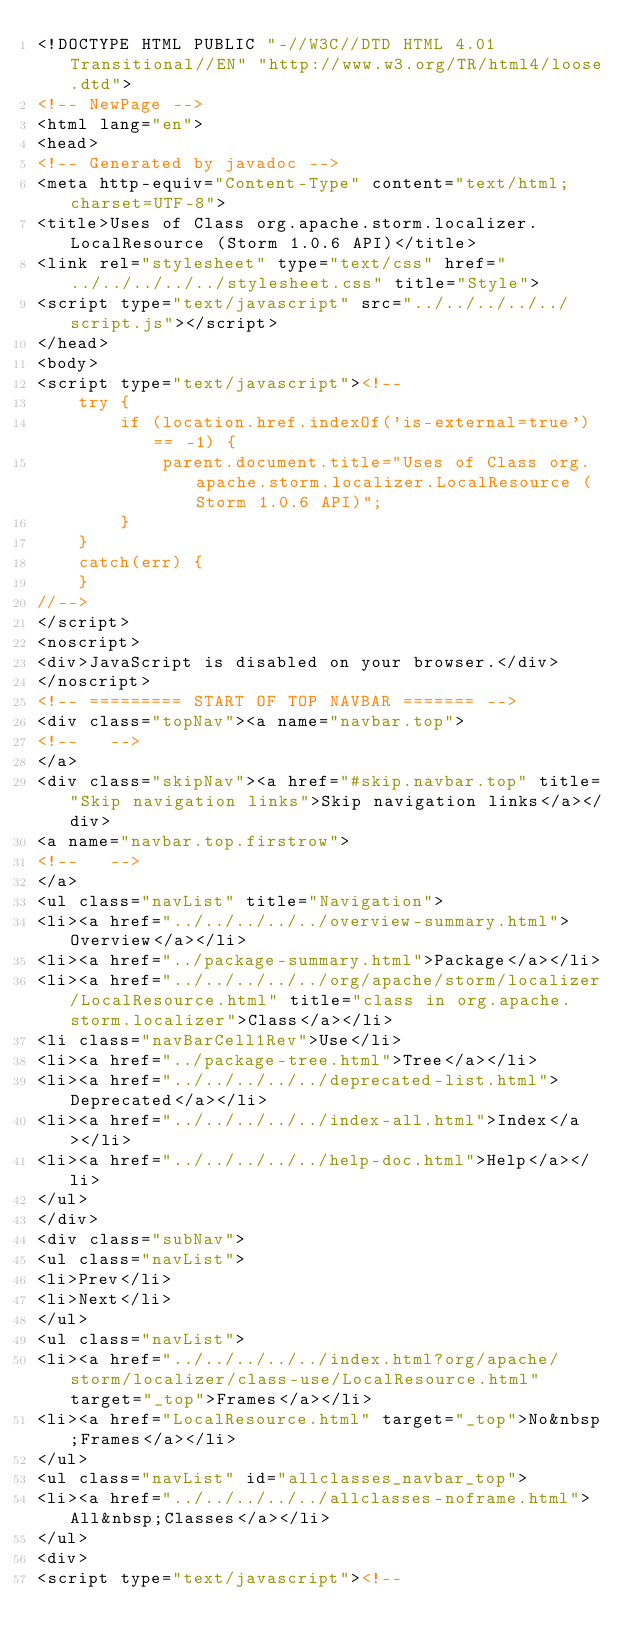<code> <loc_0><loc_0><loc_500><loc_500><_HTML_><!DOCTYPE HTML PUBLIC "-//W3C//DTD HTML 4.01 Transitional//EN" "http://www.w3.org/TR/html4/loose.dtd">
<!-- NewPage -->
<html lang="en">
<head>
<!-- Generated by javadoc -->
<meta http-equiv="Content-Type" content="text/html; charset=UTF-8">
<title>Uses of Class org.apache.storm.localizer.LocalResource (Storm 1.0.6 API)</title>
<link rel="stylesheet" type="text/css" href="../../../../../stylesheet.css" title="Style">
<script type="text/javascript" src="../../../../../script.js"></script>
</head>
<body>
<script type="text/javascript"><!--
    try {
        if (location.href.indexOf('is-external=true') == -1) {
            parent.document.title="Uses of Class org.apache.storm.localizer.LocalResource (Storm 1.0.6 API)";
        }
    }
    catch(err) {
    }
//-->
</script>
<noscript>
<div>JavaScript is disabled on your browser.</div>
</noscript>
<!-- ========= START OF TOP NAVBAR ======= -->
<div class="topNav"><a name="navbar.top">
<!--   -->
</a>
<div class="skipNav"><a href="#skip.navbar.top" title="Skip navigation links">Skip navigation links</a></div>
<a name="navbar.top.firstrow">
<!--   -->
</a>
<ul class="navList" title="Navigation">
<li><a href="../../../../../overview-summary.html">Overview</a></li>
<li><a href="../package-summary.html">Package</a></li>
<li><a href="../../../../../org/apache/storm/localizer/LocalResource.html" title="class in org.apache.storm.localizer">Class</a></li>
<li class="navBarCell1Rev">Use</li>
<li><a href="../package-tree.html">Tree</a></li>
<li><a href="../../../../../deprecated-list.html">Deprecated</a></li>
<li><a href="../../../../../index-all.html">Index</a></li>
<li><a href="../../../../../help-doc.html">Help</a></li>
</ul>
</div>
<div class="subNav">
<ul class="navList">
<li>Prev</li>
<li>Next</li>
</ul>
<ul class="navList">
<li><a href="../../../../../index.html?org/apache/storm/localizer/class-use/LocalResource.html" target="_top">Frames</a></li>
<li><a href="LocalResource.html" target="_top">No&nbsp;Frames</a></li>
</ul>
<ul class="navList" id="allclasses_navbar_top">
<li><a href="../../../../../allclasses-noframe.html">All&nbsp;Classes</a></li>
</ul>
<div>
<script type="text/javascript"><!--</code> 